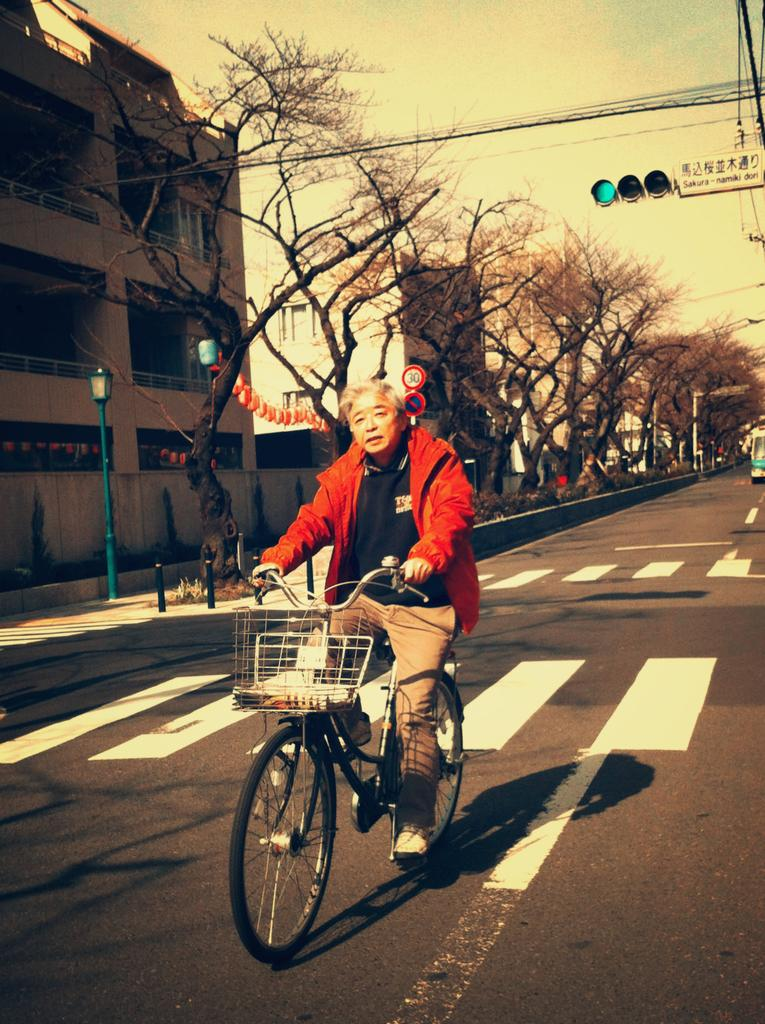Who is the main subject in the image? There is a man in the image. What is the man doing in the image? The man is riding a bicycle. Where is the bicycle located? The bicycle is on a road. What can be seen along the road in the image? The road passes through a traffic signal. What type of jam is the man eating while riding the bicycle in the image? There is no jam present in the image, and the man is not eating anything while riding the bicycle. 